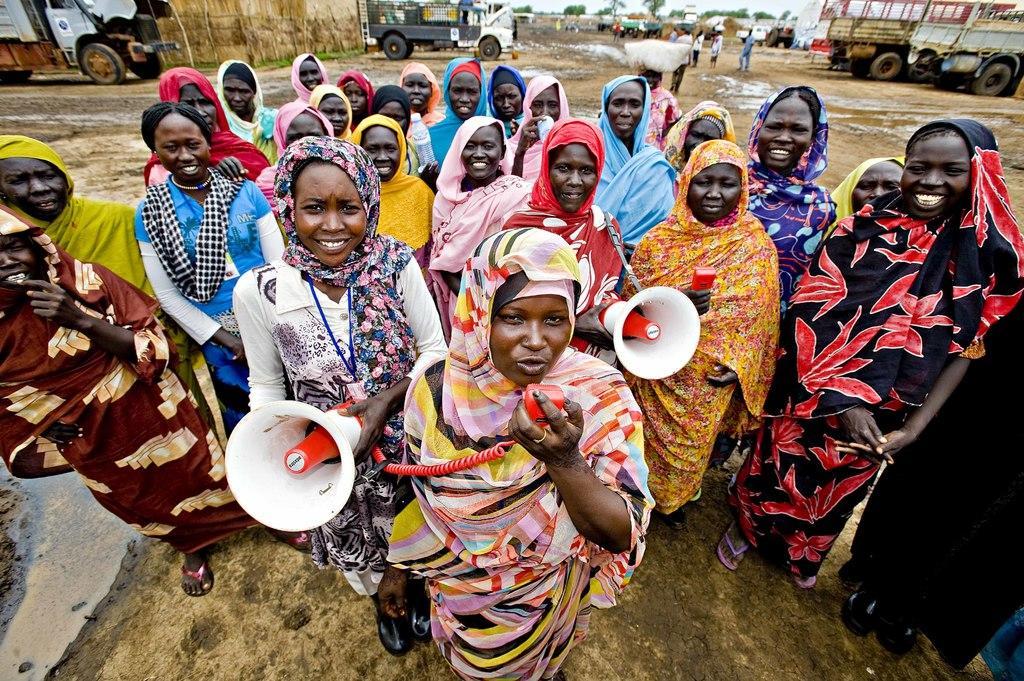Could you give a brief overview of what you see in this image? In this image we can see people and two of them are holding speakers. In the background we can see vehicles, people, ground, trees, and sky. 